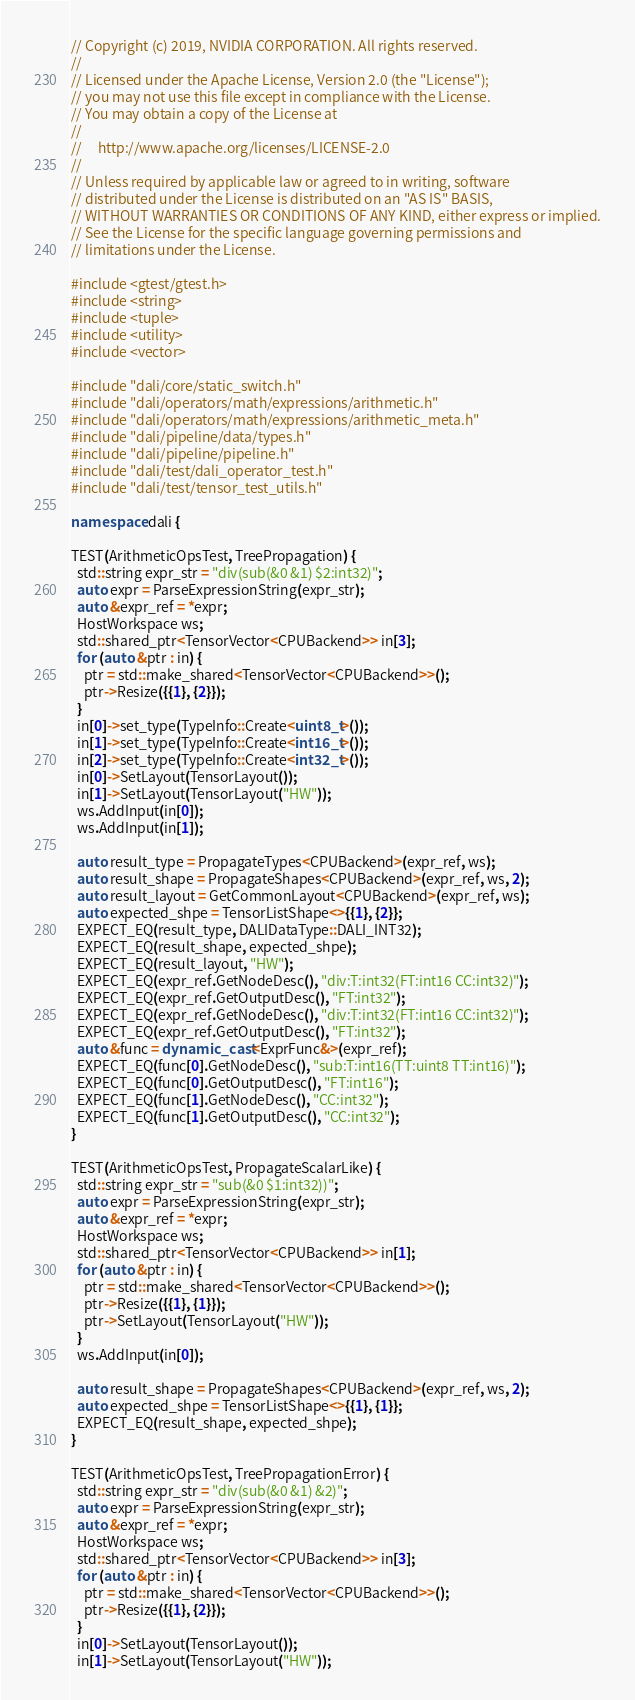Convert code to text. <code><loc_0><loc_0><loc_500><loc_500><_C++_>// Copyright (c) 2019, NVIDIA CORPORATION. All rights reserved.
//
// Licensed under the Apache License, Version 2.0 (the "License");
// you may not use this file except in compliance with the License.
// You may obtain a copy of the License at
//
//     http://www.apache.org/licenses/LICENSE-2.0
//
// Unless required by applicable law or agreed to in writing, software
// distributed under the License is distributed on an "AS IS" BASIS,
// WITHOUT WARRANTIES OR CONDITIONS OF ANY KIND, either express or implied.
// See the License for the specific language governing permissions and
// limitations under the License.

#include <gtest/gtest.h>
#include <string>
#include <tuple>
#include <utility>
#include <vector>

#include "dali/core/static_switch.h"
#include "dali/operators/math/expressions/arithmetic.h"
#include "dali/operators/math/expressions/arithmetic_meta.h"
#include "dali/pipeline/data/types.h"
#include "dali/pipeline/pipeline.h"
#include "dali/test/dali_operator_test.h"
#include "dali/test/tensor_test_utils.h"

namespace dali {

TEST(ArithmeticOpsTest, TreePropagation) {
  std::string expr_str = "div(sub(&0 &1) $2:int32)";
  auto expr = ParseExpressionString(expr_str);
  auto &expr_ref = *expr;
  HostWorkspace ws;
  std::shared_ptr<TensorVector<CPUBackend>> in[3];
  for (auto &ptr : in) {
    ptr = std::make_shared<TensorVector<CPUBackend>>();
    ptr->Resize({{1}, {2}});
  }
  in[0]->set_type(TypeInfo::Create<uint8_t>());
  in[1]->set_type(TypeInfo::Create<int16_t>());
  in[2]->set_type(TypeInfo::Create<int32_t>());
  in[0]->SetLayout(TensorLayout());
  in[1]->SetLayout(TensorLayout("HW"));
  ws.AddInput(in[0]);
  ws.AddInput(in[1]);

  auto result_type = PropagateTypes<CPUBackend>(expr_ref, ws);
  auto result_shape = PropagateShapes<CPUBackend>(expr_ref, ws, 2);
  auto result_layout = GetCommonLayout<CPUBackend>(expr_ref, ws);
  auto expected_shpe = TensorListShape<>{{1}, {2}};
  EXPECT_EQ(result_type, DALIDataType::DALI_INT32);
  EXPECT_EQ(result_shape, expected_shpe);
  EXPECT_EQ(result_layout, "HW");
  EXPECT_EQ(expr_ref.GetNodeDesc(), "div:T:int32(FT:int16 CC:int32)");
  EXPECT_EQ(expr_ref.GetOutputDesc(), "FT:int32");
  EXPECT_EQ(expr_ref.GetNodeDesc(), "div:T:int32(FT:int16 CC:int32)");
  EXPECT_EQ(expr_ref.GetOutputDesc(), "FT:int32");
  auto &func = dynamic_cast<ExprFunc&>(expr_ref);
  EXPECT_EQ(func[0].GetNodeDesc(), "sub:T:int16(TT:uint8 TT:int16)");
  EXPECT_EQ(func[0].GetOutputDesc(), "FT:int16");
  EXPECT_EQ(func[1].GetNodeDesc(), "CC:int32");
  EXPECT_EQ(func[1].GetOutputDesc(), "CC:int32");
}

TEST(ArithmeticOpsTest, PropagateScalarLike) {
  std::string expr_str = "sub(&0 $1:int32))";
  auto expr = ParseExpressionString(expr_str);
  auto &expr_ref = *expr;
  HostWorkspace ws;
  std::shared_ptr<TensorVector<CPUBackend>> in[1];
  for (auto &ptr : in) {
    ptr = std::make_shared<TensorVector<CPUBackend>>();
    ptr->Resize({{1}, {1}});
    ptr->SetLayout(TensorLayout("HW"));
  }
  ws.AddInput(in[0]);

  auto result_shape = PropagateShapes<CPUBackend>(expr_ref, ws, 2);
  auto expected_shpe = TensorListShape<>{{1}, {1}};
  EXPECT_EQ(result_shape, expected_shpe);
}

TEST(ArithmeticOpsTest, TreePropagationError) {
  std::string expr_str = "div(sub(&0 &1) &2)";
  auto expr = ParseExpressionString(expr_str);
  auto &expr_ref = *expr;
  HostWorkspace ws;
  std::shared_ptr<TensorVector<CPUBackend>> in[3];
  for (auto &ptr : in) {
    ptr = std::make_shared<TensorVector<CPUBackend>>();
    ptr->Resize({{1}, {2}});
  }
  in[0]->SetLayout(TensorLayout());
  in[1]->SetLayout(TensorLayout("HW"));</code> 